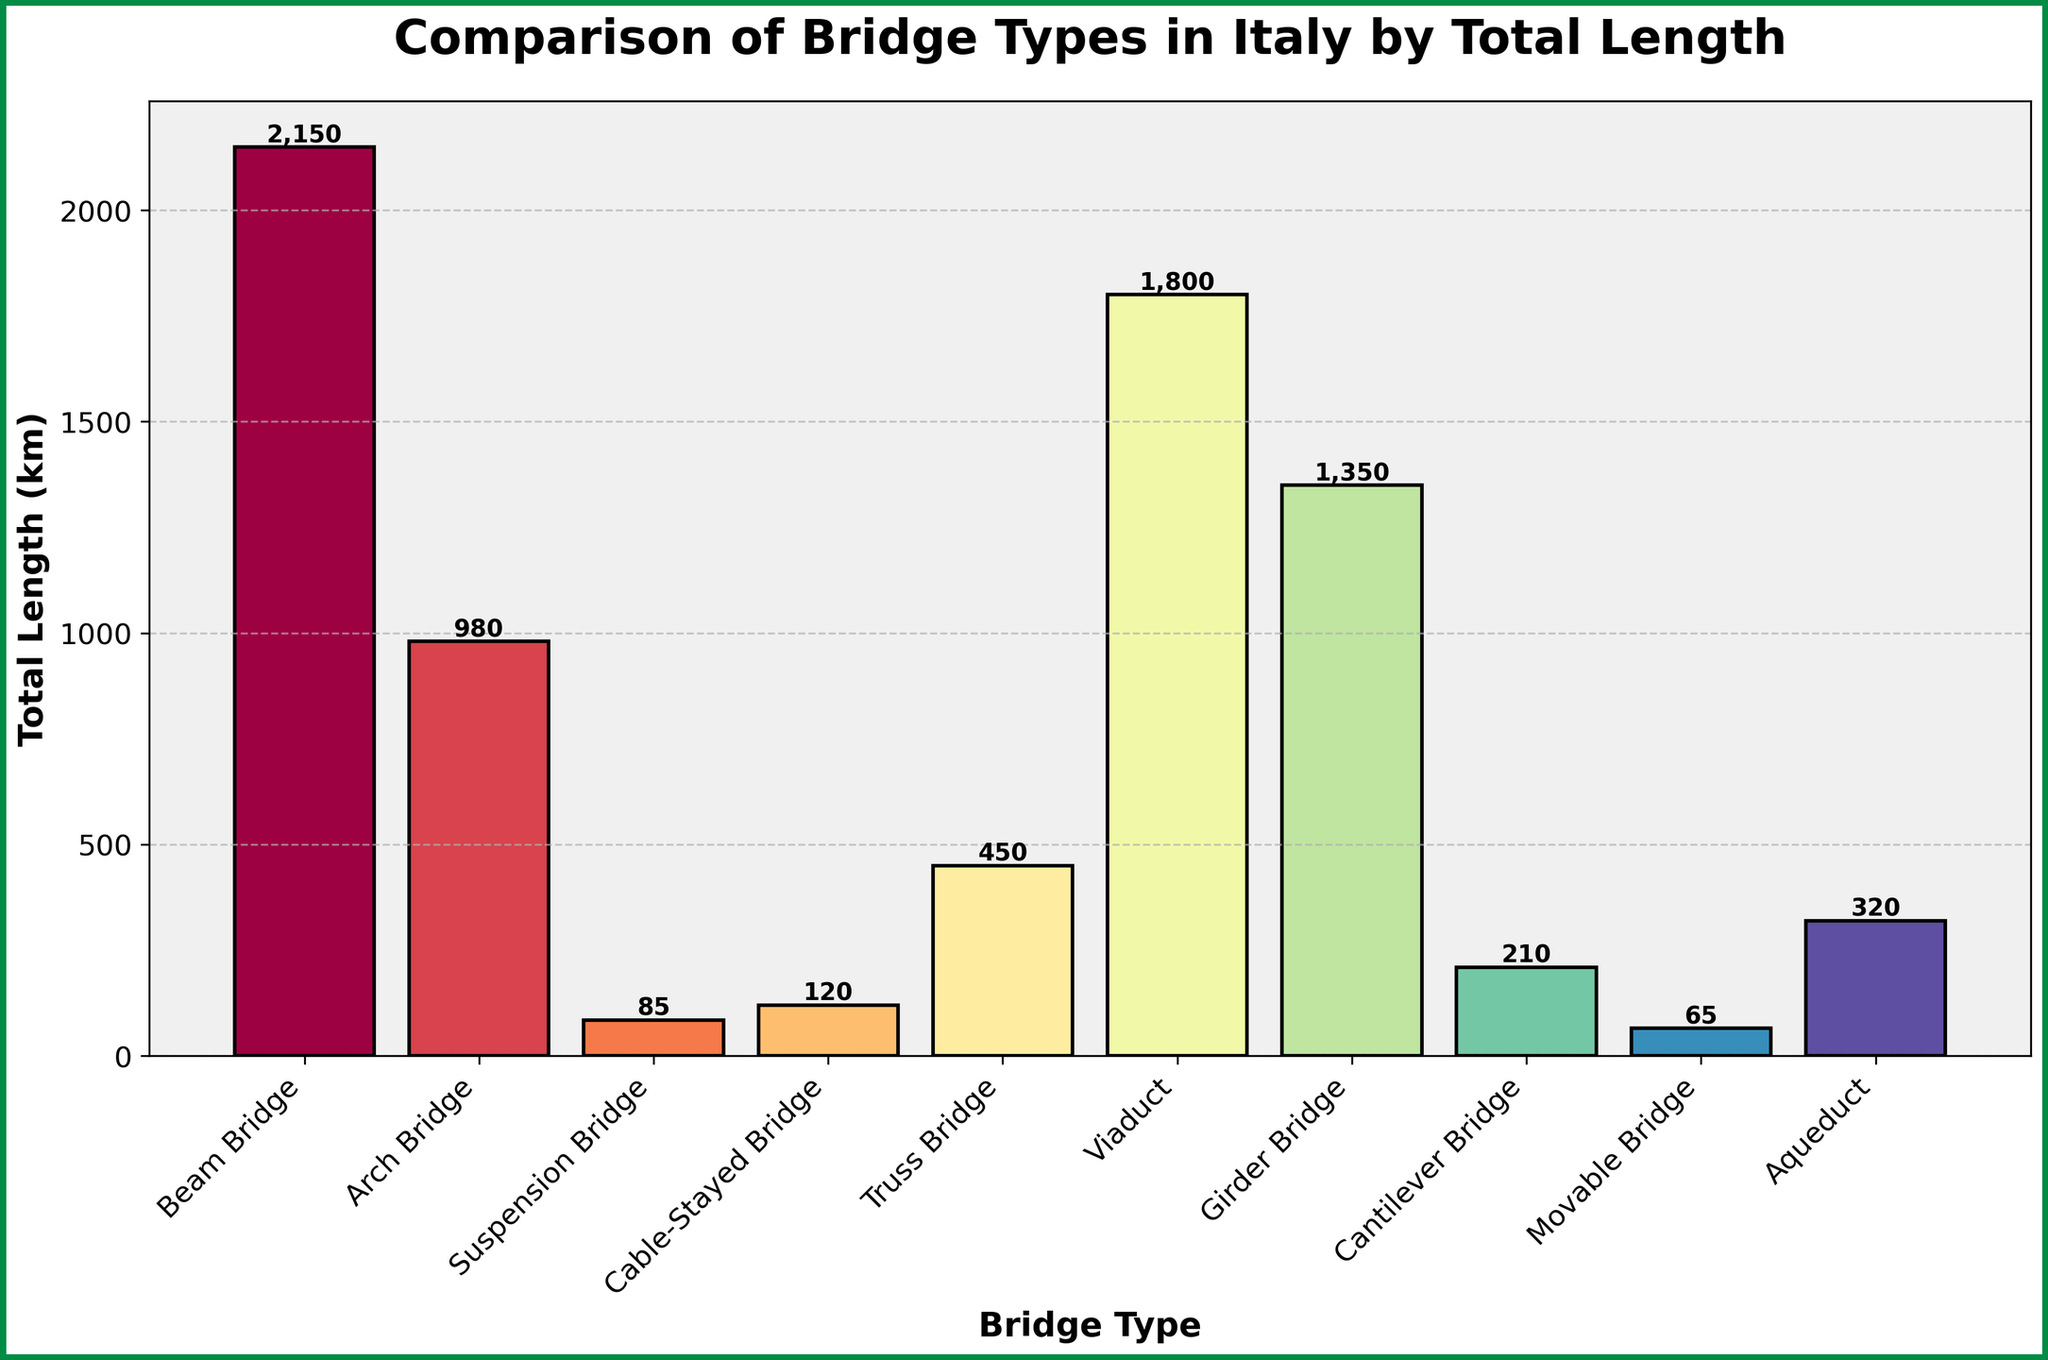Which bridge type in Italy has the greatest total length? The bar chart shows various bridge types and their total lengths. The bar for Beam Bridge is the tallest, indicating it has the greatest total length.
Answer: Beam Bridge Which bridge type has a longer total length, Suspension Bridge or Cable-Stayed Bridge? By directly comparing the heights of the bars for Suspension Bridge and Cable-Stayed Bridge, the bar for Cable-Stayed Bridge is slightly taller.
Answer: Cable-Stayed Bridge What is the combined total length of Truss Bridge and Girder Bridge? The total length for Truss Bridge is 450 km and for Girder Bridge is 1350 km. Adding these together gives 450 + 1350 = 1800 km.
Answer: 1800 km Which bridge type has the shortest total length, and what is that length? The bar for Movable Bridge is the shortest on the chart, indicating it has the shortest total length, which is 65 km.
Answer: Movable Bridge, 65 km How much longer is the total length of Beam Bridge compared to Arch Bridge? The total length of Beam Bridge is 2150 km, and that of Arch Bridge is 980 km. The difference is 2150 - 980 = 1170 km.
Answer: 1170 km How many bridge types have a total length greater than 1000 km? The bars representing Beam Bridge (2150 km), Viaduct (1800 km), and Girder Bridge (1350 km) are all above the 1000 km mark. Hence, there are 3 such bridge types.
Answer: 3 If you combine the total lengths of Cantilever Bridge, Movable Bridge, and Aqueduct, does it surpass the length of Viaduct? The total lengths are Cantilever Bridge (210 km), Movable Bridge (65 km), and Aqueduct (320 km). Combining these, 210 + 65 + 320 = 595 km, which is less than the total length of the Viaduct (1800 km).
Answer: No Which bridge type is more than double the total length of Suspension Bridge but less than Girder Bridge? Suspension Bridge has a total length of 85 km. Double this is 85 * 2 = 170 km. Comparing this to other bridge type lengths, Cantilever Bridge (210 km) fits the condition of being more than 170 km but less than Girder Bridge (1350 km).
Answer: Cantilever Bridge 